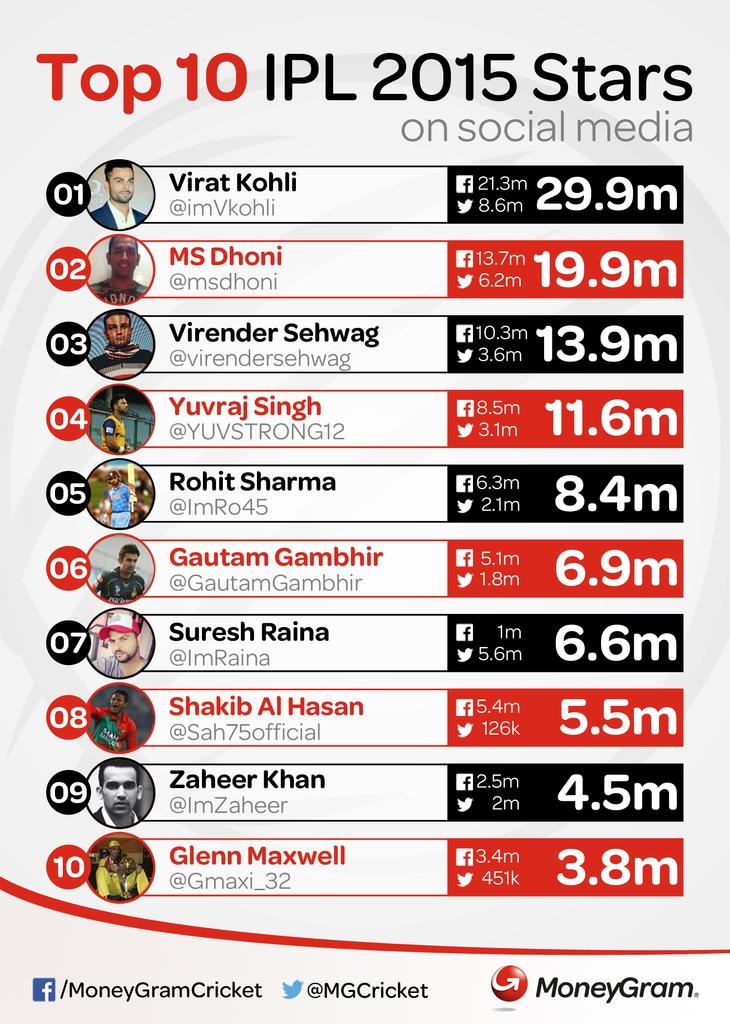Highlight a few significant elements in this photo. Virat Kohli has 2.4 more million followers than Dhoni on Twitter. Glenn Maxwell has the second lowest number of followers on Twitter. All of these players belong to the sport of cricket, whereas none belong to the sport of football. Virat Kohli has 8.6 million followers on Twitter. Suresh Raina has more followers on Twitter than on Facebook. 